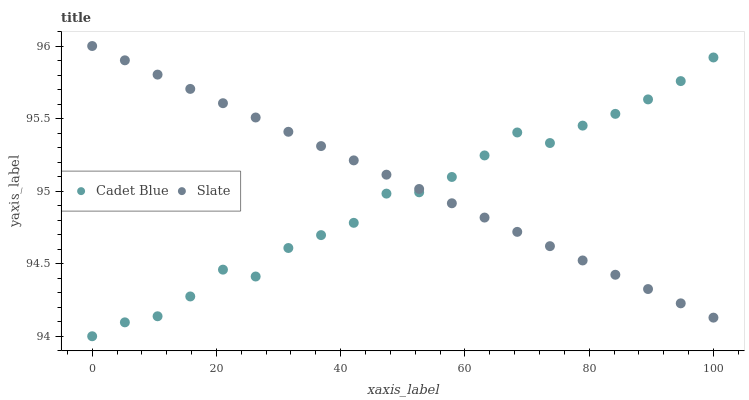Does Cadet Blue have the minimum area under the curve?
Answer yes or no. Yes. Does Slate have the maximum area under the curve?
Answer yes or no. Yes. Does Cadet Blue have the maximum area under the curve?
Answer yes or no. No. Is Slate the smoothest?
Answer yes or no. Yes. Is Cadet Blue the roughest?
Answer yes or no. Yes. Is Cadet Blue the smoothest?
Answer yes or no. No. Does Cadet Blue have the lowest value?
Answer yes or no. Yes. Does Slate have the highest value?
Answer yes or no. Yes. Does Cadet Blue have the highest value?
Answer yes or no. No. Does Cadet Blue intersect Slate?
Answer yes or no. Yes. Is Cadet Blue less than Slate?
Answer yes or no. No. Is Cadet Blue greater than Slate?
Answer yes or no. No. 